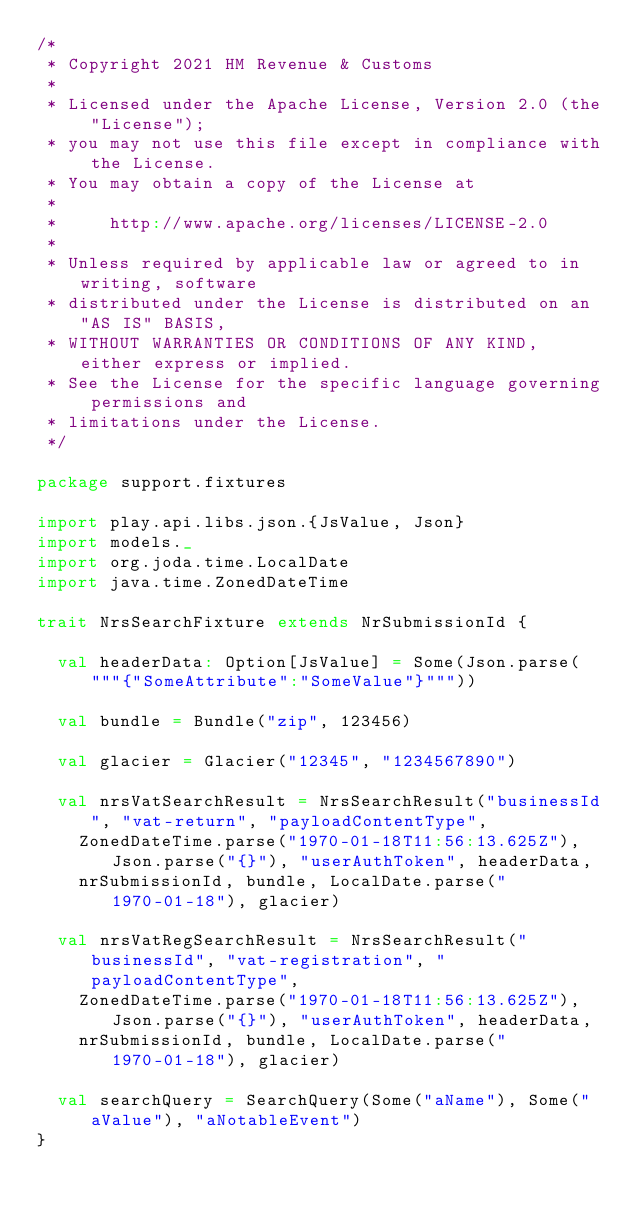<code> <loc_0><loc_0><loc_500><loc_500><_Scala_>/*
 * Copyright 2021 HM Revenue & Customs
 *
 * Licensed under the Apache License, Version 2.0 (the "License");
 * you may not use this file except in compliance with the License.
 * You may obtain a copy of the License at
 *
 *     http://www.apache.org/licenses/LICENSE-2.0
 *
 * Unless required by applicable law or agreed to in writing, software
 * distributed under the License is distributed on an "AS IS" BASIS,
 * WITHOUT WARRANTIES OR CONDITIONS OF ANY KIND, either express or implied.
 * See the License for the specific language governing permissions and
 * limitations under the License.
 */

package support.fixtures

import play.api.libs.json.{JsValue, Json}
import models._
import org.joda.time.LocalDate
import java.time.ZonedDateTime

trait NrsSearchFixture extends NrSubmissionId {

  val headerData: Option[JsValue] = Some(Json.parse("""{"SomeAttribute":"SomeValue"}"""))

  val bundle = Bundle("zip", 123456)

  val glacier = Glacier("12345", "1234567890")

  val nrsVatSearchResult = NrsSearchResult("businessId", "vat-return", "payloadContentType",
    ZonedDateTime.parse("1970-01-18T11:56:13.625Z"), Json.parse("{}"), "userAuthToken", headerData,
    nrSubmissionId, bundle, LocalDate.parse("1970-01-18"), glacier)

  val nrsVatRegSearchResult = NrsSearchResult("businessId", "vat-registration", "payloadContentType",
    ZonedDateTime.parse("1970-01-18T11:56:13.625Z"), Json.parse("{}"), "userAuthToken", headerData,
    nrSubmissionId, bundle, LocalDate.parse("1970-01-18"), glacier)

  val searchQuery = SearchQuery(Some("aName"), Some("aValue"), "aNotableEvent")
}
</code> 